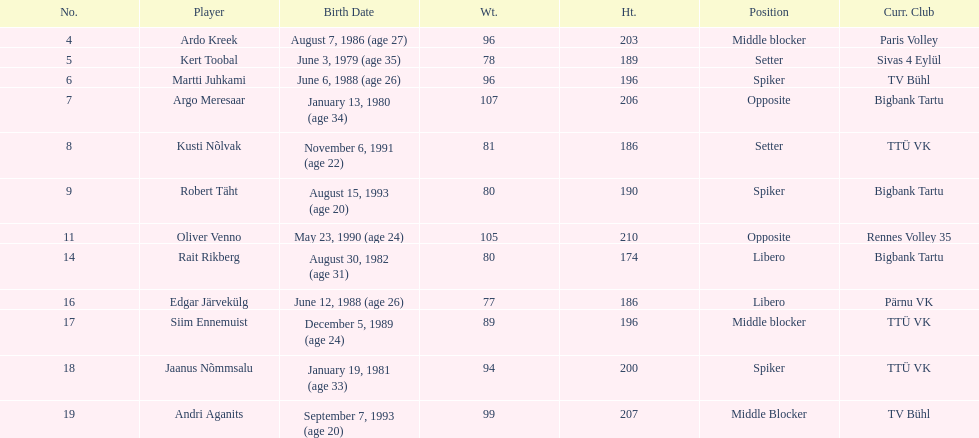How many players are middle blockers? 3. 